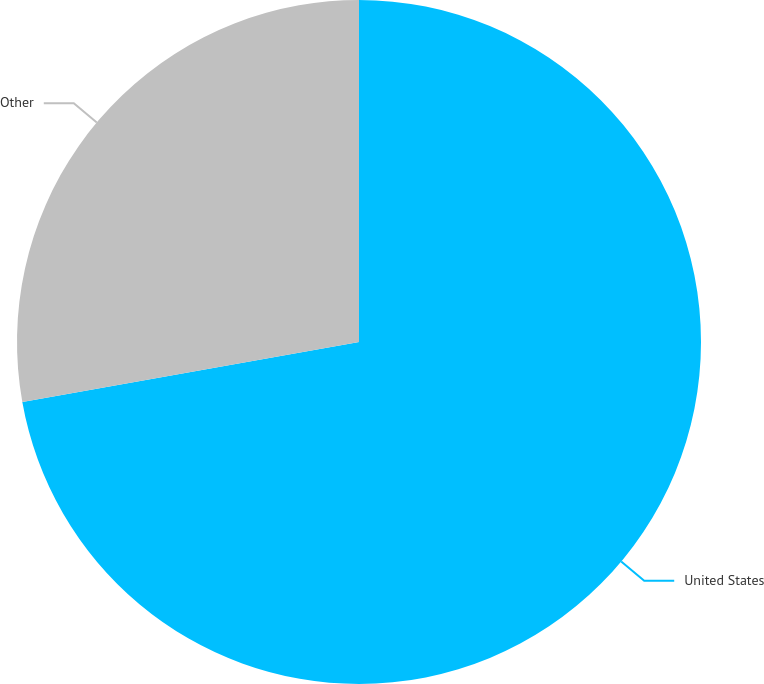<chart> <loc_0><loc_0><loc_500><loc_500><pie_chart><fcel>United States<fcel>Other<nl><fcel>72.19%<fcel>27.81%<nl></chart> 